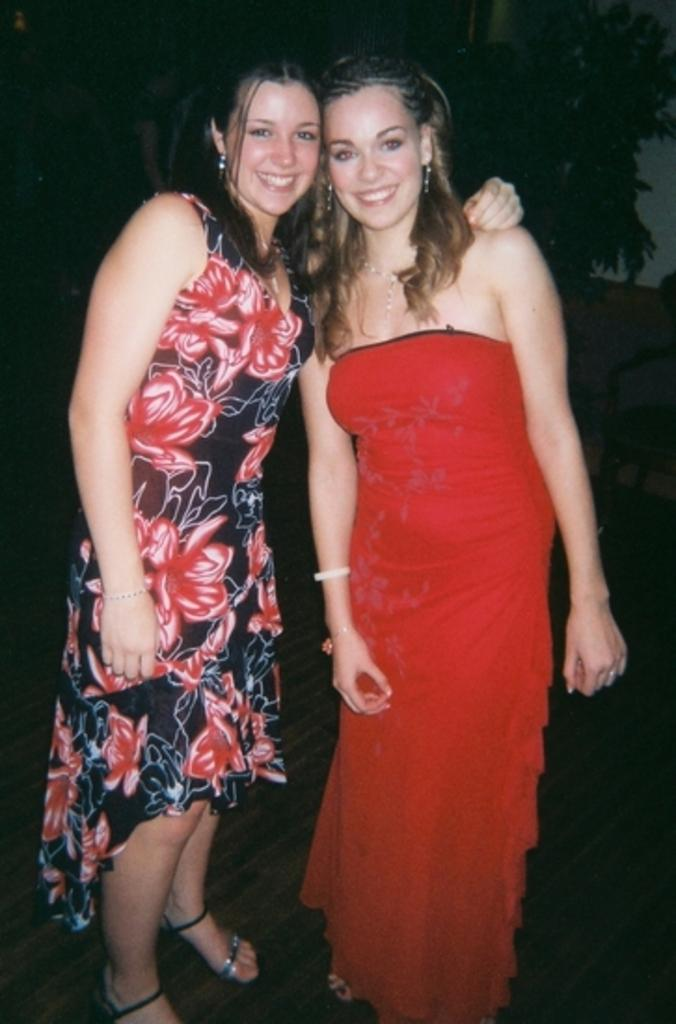How many people are in the image? There are two women in the image. What are the women doing in the image? The women are standing and smiling. What can be observed about the background of the image? The background of the image is dark. What type of animals can be seen in the background of the image? There are no animals visible in the image, as the background is dark and does not show any animals or a zoo setting. 